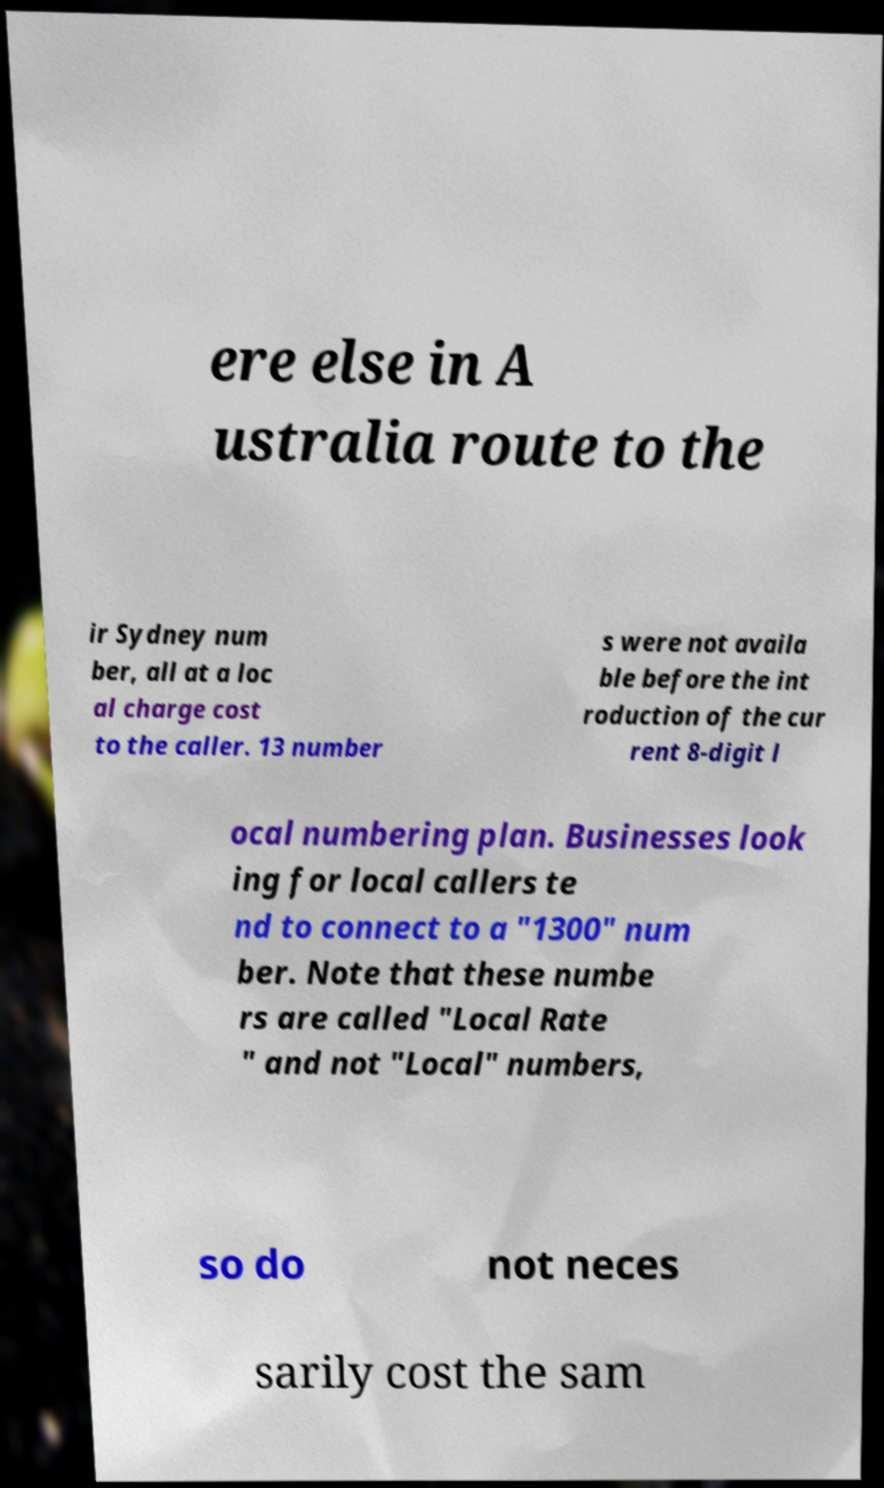Can you read and provide the text displayed in the image?This photo seems to have some interesting text. Can you extract and type it out for me? ere else in A ustralia route to the ir Sydney num ber, all at a loc al charge cost to the caller. 13 number s were not availa ble before the int roduction of the cur rent 8-digit l ocal numbering plan. Businesses look ing for local callers te nd to connect to a "1300" num ber. Note that these numbe rs are called "Local Rate " and not "Local" numbers, so do not neces sarily cost the sam 